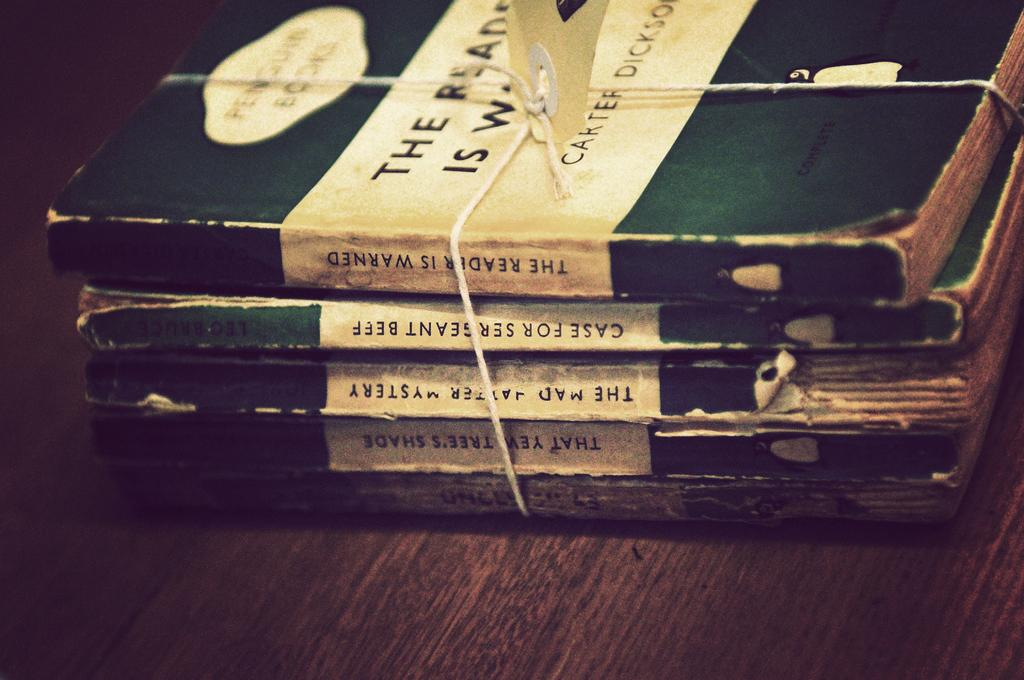What objects can be seen in the image? There are books in the image. Where are the books located? The books are on a table. Can you describe the harbor in the image? There is no harbor present in the image; it only features books on a table. What type of shade is provided by the books in the image? The books in the image do not provide any shade, as they are not blocking any light source. 